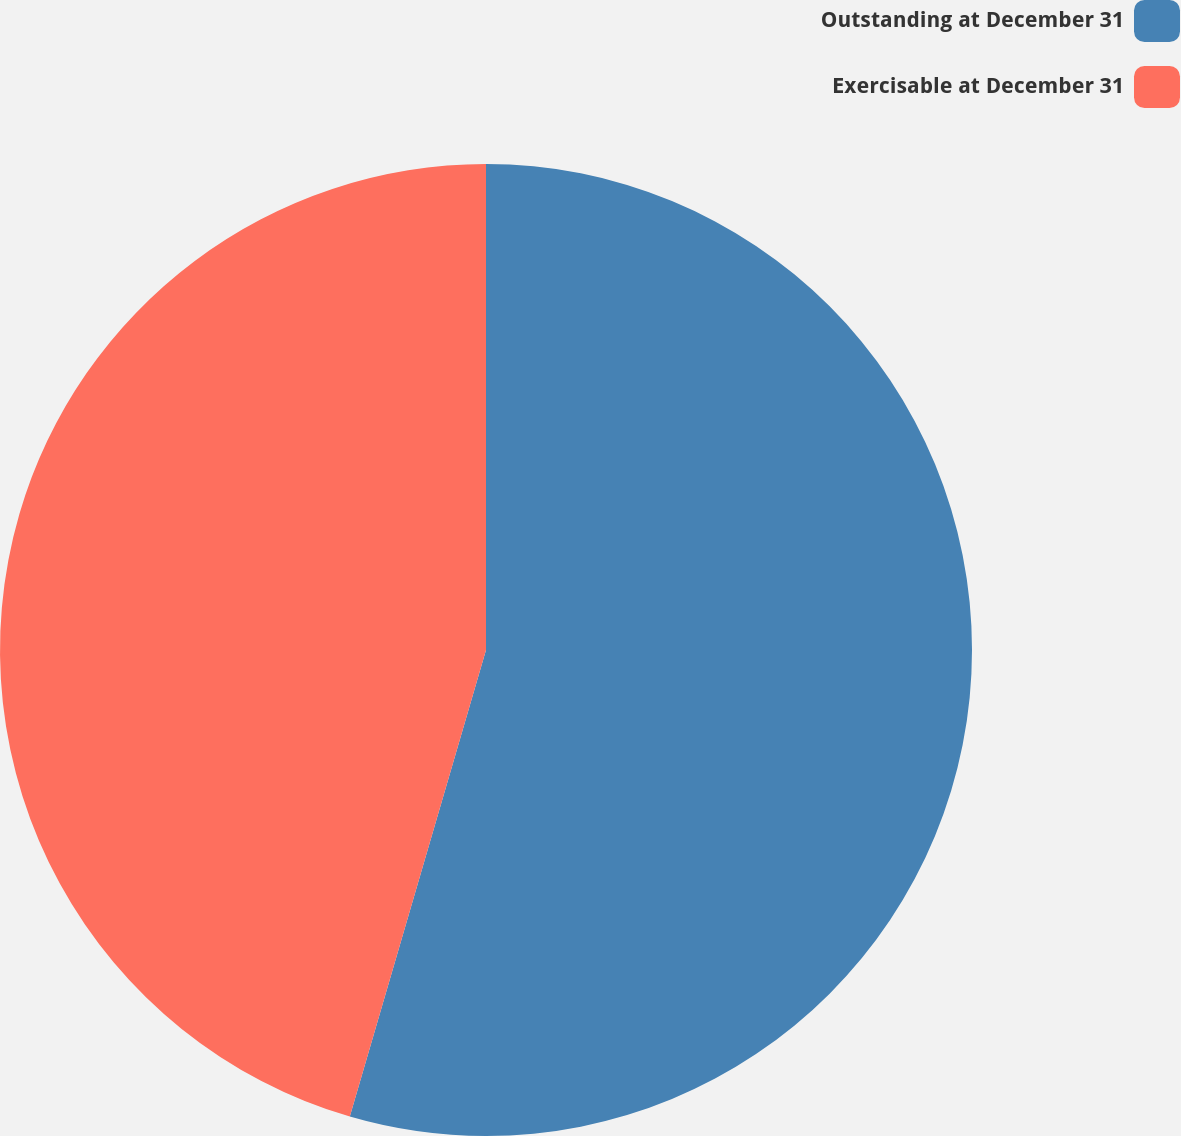<chart> <loc_0><loc_0><loc_500><loc_500><pie_chart><fcel>Outstanding at December 31<fcel>Exercisable at December 31<nl><fcel>54.52%<fcel>45.48%<nl></chart> 